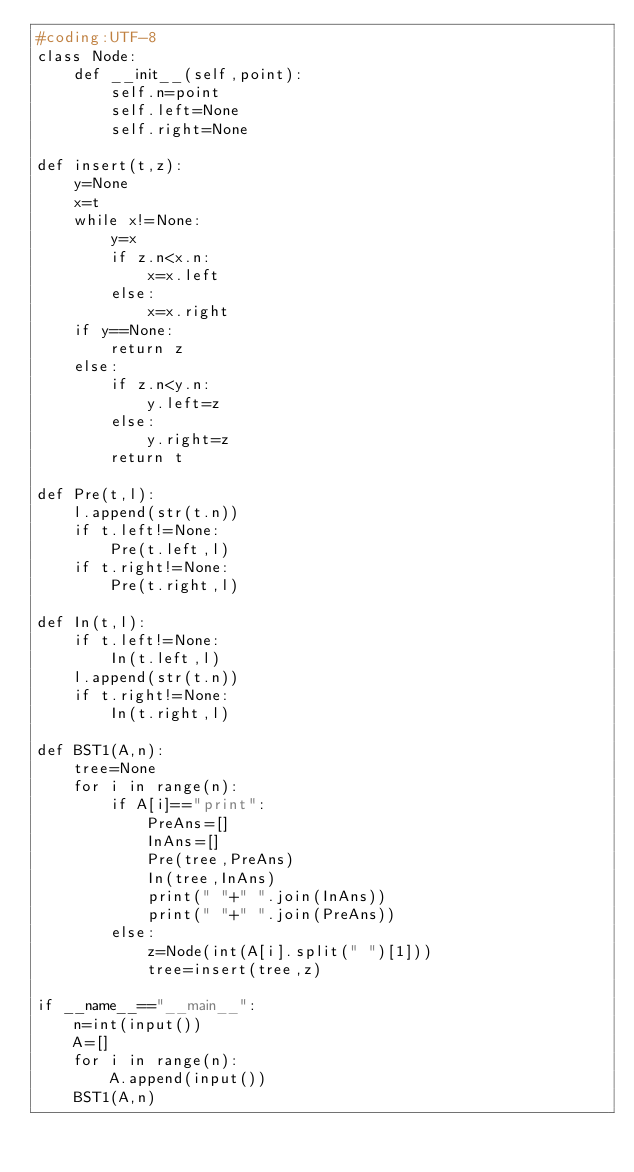Convert code to text. <code><loc_0><loc_0><loc_500><loc_500><_Python_>#coding:UTF-8
class Node:
    def __init__(self,point):
        self.n=point
        self.left=None
        self.right=None
        
def insert(t,z):
    y=None
    x=t
    while x!=None:
        y=x
        if z.n<x.n:
            x=x.left
        else:
            x=x.right
    if y==None:
        return z
    else:
        if z.n<y.n:
            y.left=z
        else:
            y.right=z
        return t

def Pre(t,l):
    l.append(str(t.n))
    if t.left!=None:
        Pre(t.left,l)
    if t.right!=None:
        Pre(t.right,l)

def In(t,l):
    if t.left!=None:
        In(t.left,l)
    l.append(str(t.n))
    if t.right!=None:
        In(t.right,l)

def BST1(A,n):
    tree=None
    for i in range(n):
        if A[i]=="print":
            PreAns=[]
            InAns=[]
            Pre(tree,PreAns)
            In(tree,InAns)
            print(" "+" ".join(InAns))
            print(" "+" ".join(PreAns))
        else:
            z=Node(int(A[i].split(" ")[1]))
            tree=insert(tree,z)
            
if __name__=="__main__":
    n=int(input())
    A=[]
    for i in range(n):
        A.append(input())
    BST1(A,n)</code> 